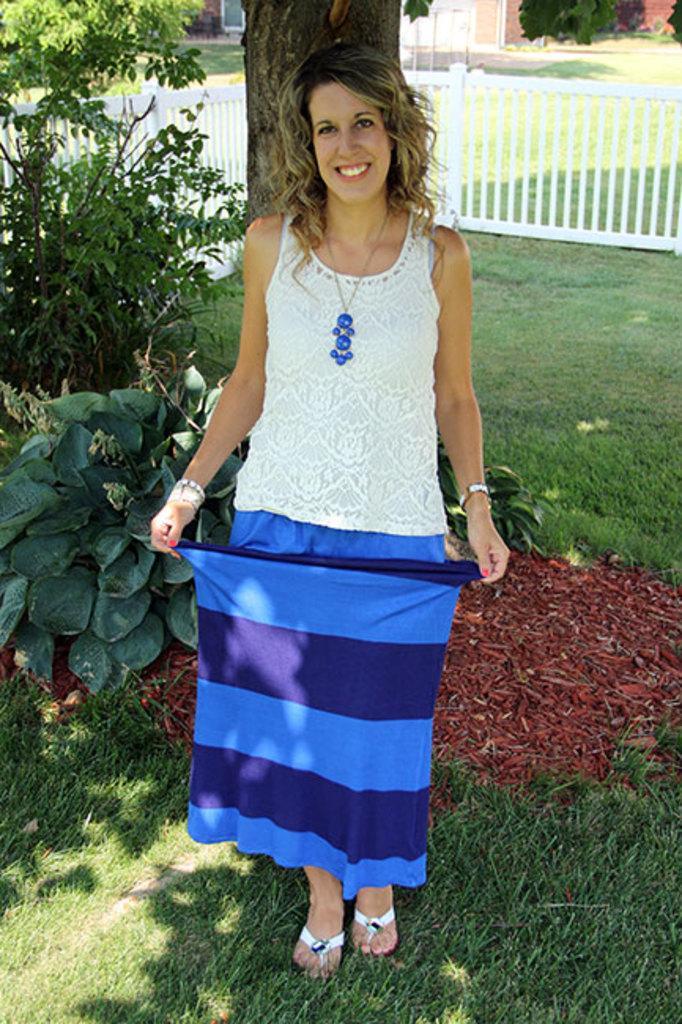How would you summarize this image in a sentence or two? This picture might be taken from outside of the city. In this image, in the middle, we can see a woman standing on the grass. On the left side, we can see some plants, grills, trees. In the background, we can see a wooden trunk, grill, trees, building. At the bottom, we can see a grass. 